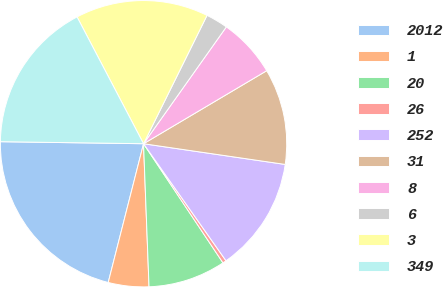<chart> <loc_0><loc_0><loc_500><loc_500><pie_chart><fcel>2012<fcel>1<fcel>20<fcel>26<fcel>252<fcel>31<fcel>8<fcel>6<fcel>3<fcel>349<nl><fcel>21.26%<fcel>4.58%<fcel>8.75%<fcel>0.41%<fcel>12.92%<fcel>10.83%<fcel>6.67%<fcel>2.5%<fcel>15.0%<fcel>17.09%<nl></chart> 